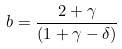<formula> <loc_0><loc_0><loc_500><loc_500>b = \frac { 2 + \gamma } { ( 1 + \gamma - \delta ) }</formula> 